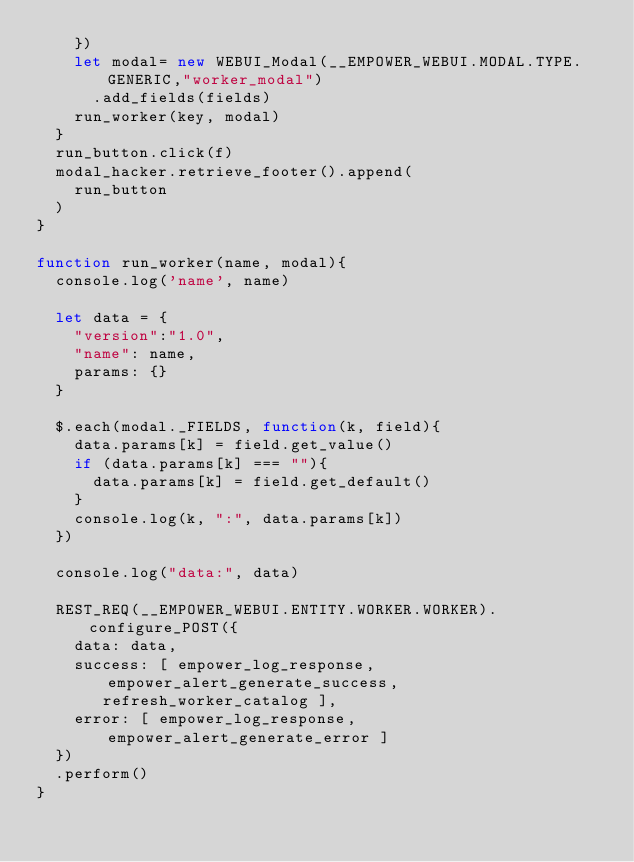Convert code to text. <code><loc_0><loc_0><loc_500><loc_500><_JavaScript_>    })
    let modal= new WEBUI_Modal(__EMPOWER_WEBUI.MODAL.TYPE.GENERIC,"worker_modal")
      .add_fields(fields)
    run_worker(key, modal)
  }
  run_button.click(f)
  modal_hacker.retrieve_footer().append(
    run_button
  )
}

function run_worker(name, modal){
  console.log('name', name)

  let data = {
    "version":"1.0",
    "name": name,
    params: {}
  }

  $.each(modal._FIELDS, function(k, field){
    data.params[k] = field.get_value()
    if (data.params[k] === ""){
      data.params[k] = field.get_default()
    }
    console.log(k, ":", data.params[k])
  })

  console.log("data:", data)

  REST_REQ(__EMPOWER_WEBUI.ENTITY.WORKER.WORKER).configure_POST({
    data: data,
    success: [ empower_log_response, empower_alert_generate_success,
       refresh_worker_catalog ],
    error: [ empower_log_response, empower_alert_generate_error ]
  })
  .perform()
}

</code> 